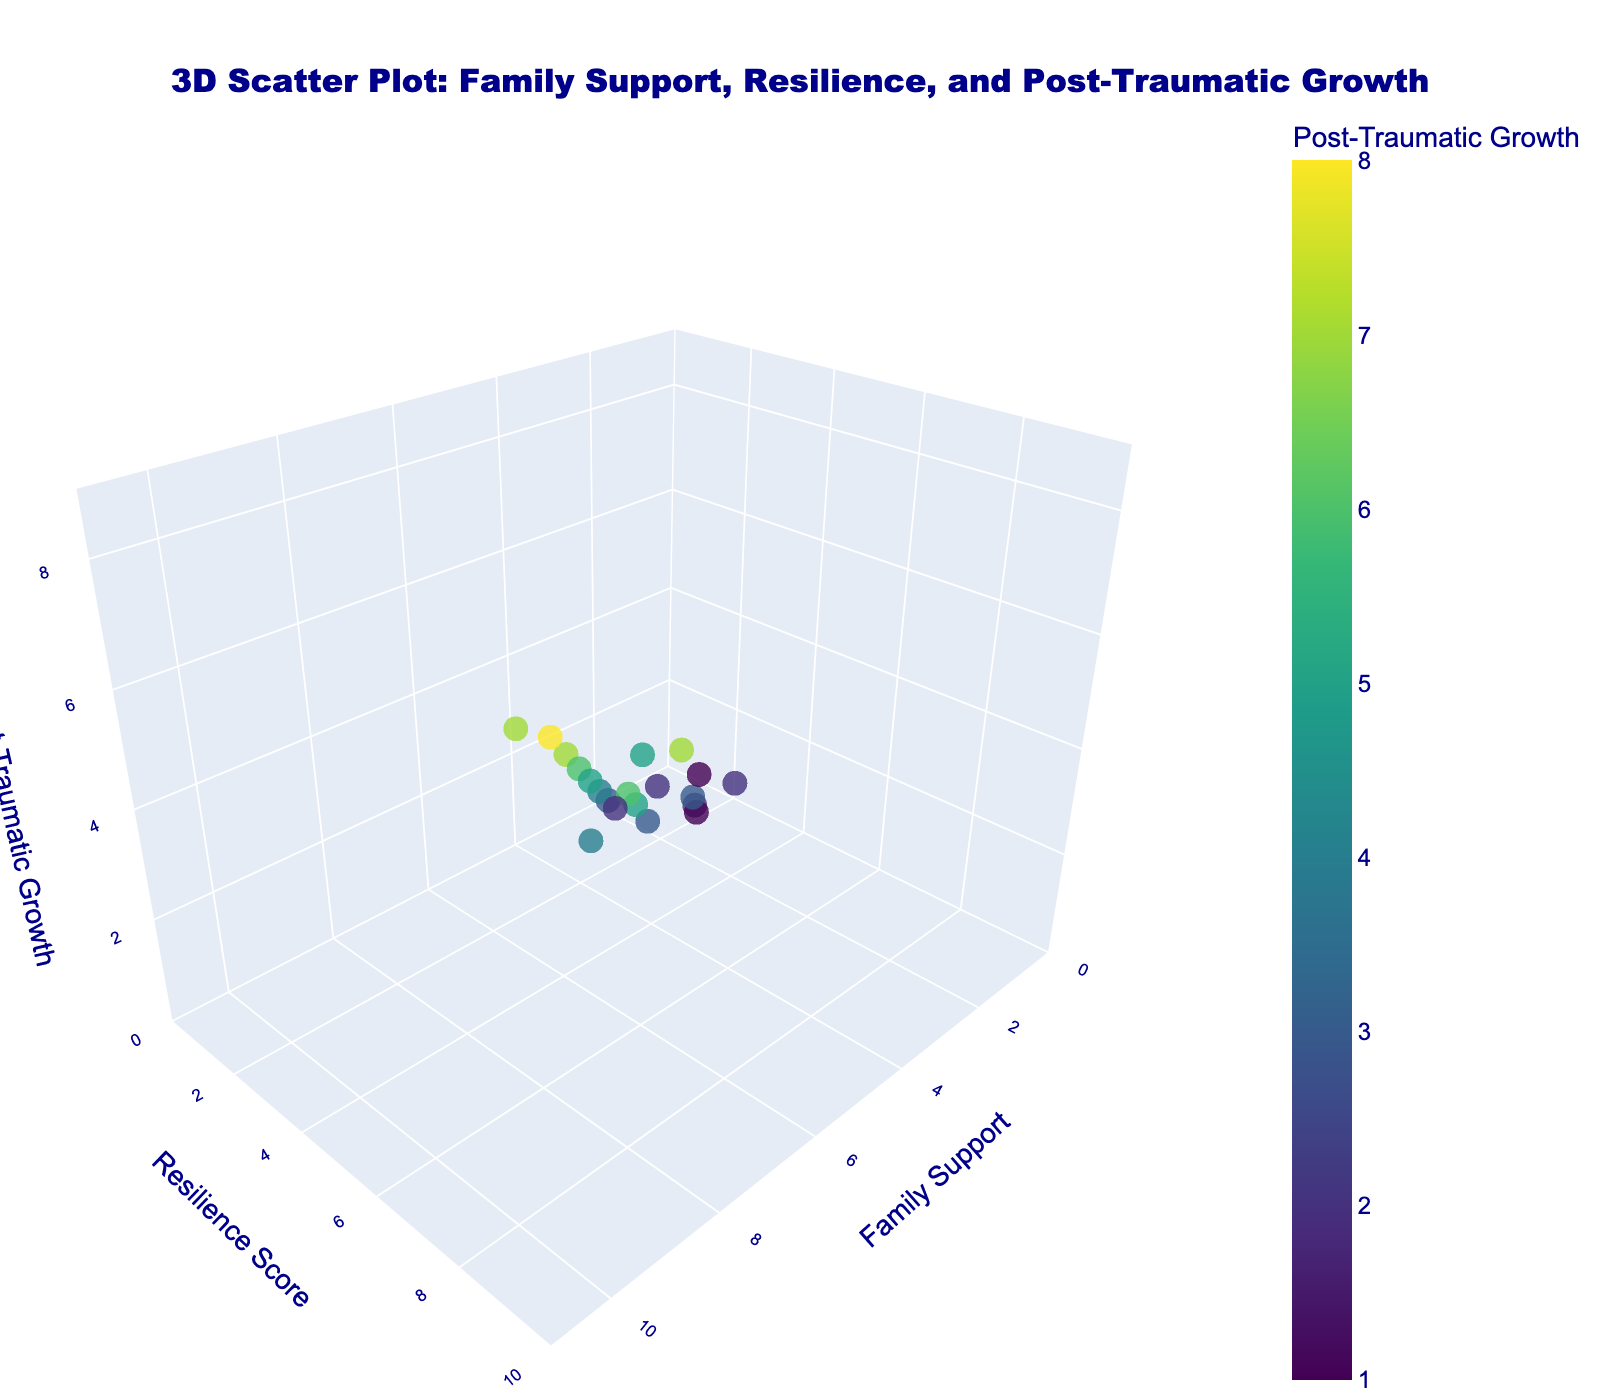what is the title of the figure? The title is usually displayed at the top of the plot and briefly describes what the figure is about.
Answer: 3D Scatter Plot: Family Support, Resilience, and Post-Traumatic Growth How many data points are displayed in the scatter plot? Each individual marker in the scatter plot represents a single data point. Counting each of these markers gives you the total number of data points.
Answer: 20 Which axis represents Family Support? The axes are labeled with titles to indicate what each one represents. Look for the text "Family Support" next to an axis line.
Answer: x-axis What is the range of the Resilience Score axis? The range of an axis can be determined by reading the minimum and maximum values labeled on that axis.
Answer: 0 to 10 Which data point has the highest Post-Traumatic Growth value? The value of Post-Traumatic Growth for each data point is shown by the z-coordinate and can be checked by finding the highest z value. Additionally, tooltip or color shading guided by the color bar is also useful.
Answer: 10,9,8 Is there a correlation between Family Support and Post-Traumatic Growth observable in the figure? By examining the upward trend or clustering pattern within the scatter plot, we can infer potential correlations. Here, higher Family Support often coincides with higher Post-Traumatic Growth.
Answer: Yes Which data points have a Resilience Score of 6? To find these, look at the y-axis values and identify the markers that are aligned with a Resilience Score of 6.
Answer: (7,6,4), (6,6,5), (7,6,5) How many data points have their Family Support value between 4 and 7? Count the number of markers situated along the x-axis between values 4 and 7 inclusive.
Answer: 7 Which data point exhibits the lowest values across all three dimensions? Locate the marker with the smallest x, y, and z values by comparing each data point's three coordinates.
Answer: (1,2,1) What can you infer about children with high Family Support in terms of their Resilience Scores and Post-Traumatic Growth? Data points with high Family Support values (closer to 10 on the x-axis) generally have relatively higher Resilience Scores and Post-Traumatic Growth values, indicating a positive relationship between these factors.
Answer: Positive relationship 